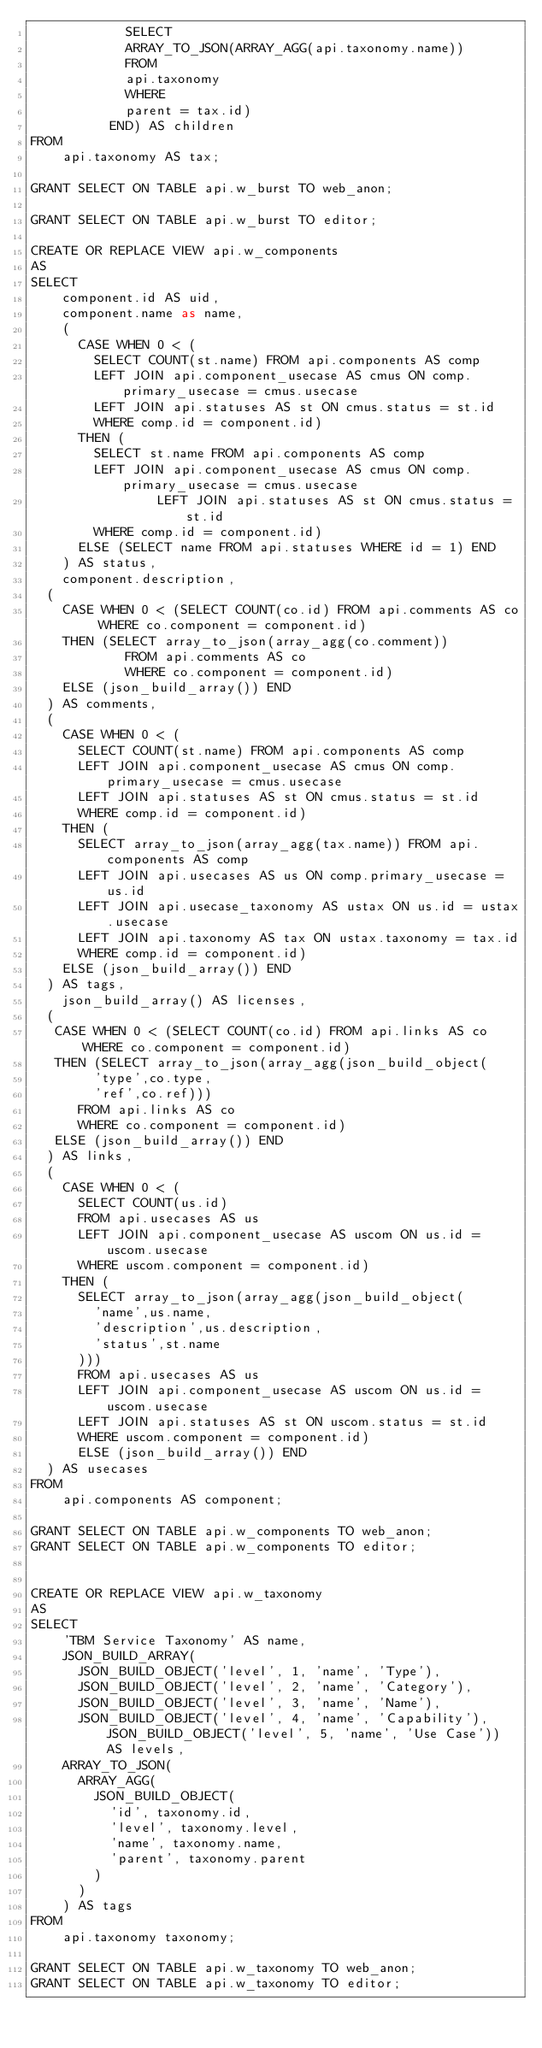<code> <loc_0><loc_0><loc_500><loc_500><_SQL_>            SELECT
            ARRAY_TO_JSON(ARRAY_AGG(api.taxonomy.name))
            FROM
            api.taxonomy
            WHERE
            parent = tax.id)
          END) AS children
FROM
    api.taxonomy AS tax;

GRANT SELECT ON TABLE api.w_burst TO web_anon;

GRANT SELECT ON TABLE api.w_burst TO editor;

CREATE OR REPLACE VIEW api.w_components
AS
SELECT
    component.id AS uid,
    component.name as name,
    (
      CASE WHEN 0 < (
        SELECT COUNT(st.name) FROM api.components AS comp
        LEFT JOIN api.component_usecase AS cmus ON comp.primary_usecase = cmus.usecase
        LEFT JOIN api.statuses AS st ON cmus.status = st.id
        WHERE comp.id = component.id)
      THEN (
        SELECT st.name FROM api.components AS comp
        LEFT JOIN api.component_usecase AS cmus ON comp.primary_usecase = cmus.usecase
                LEFT JOIN api.statuses AS st ON cmus.status = st.id
        WHERE comp.id = component.id)
      ELSE (SELECT name FROM api.statuses WHERE id = 1) END
    ) AS status,
    component.description,
	(
    CASE WHEN 0 < (SELECT COUNT(co.id) FROM api.comments AS co WHERE co.component = component.id)
    THEN (SELECT array_to_json(array_agg(co.comment))
            FROM api.comments AS co
            WHERE co.component = component.id)
    ELSE (json_build_array()) END
	) AS comments,
  (
    CASE WHEN 0 < (
      SELECT COUNT(st.name) FROM api.components AS comp
      LEFT JOIN api.component_usecase AS cmus ON comp.primary_usecase = cmus.usecase
      LEFT JOIN api.statuses AS st ON cmus.status = st.id
      WHERE comp.id = component.id)
    THEN (
      SELECT array_to_json(array_agg(tax.name)) FROM api.components AS comp
      LEFT JOIN api.usecases AS us ON comp.primary_usecase = us.id
      LEFT JOIN api.usecase_taxonomy AS ustax ON us.id = ustax.usecase
      LEFT JOIN api.taxonomy AS tax ON ustax.taxonomy = tax.id
      WHERE comp.id = component.id)
    ELSE (json_build_array()) END
  ) AS tags,
    json_build_array() AS licenses,
	(
	 CASE WHEN 0 < (SELECT COUNT(co.id) FROM api.links AS co WHERE co.component = component.id)
	 THEN (SELECT array_to_json(array_agg(json_build_object(
        'type',co.type,
        'ref',co.ref)))
      FROM api.links AS co
      WHERE co.component = component.id)
	 ELSE (json_build_array()) END
	) AS links,
  (
    CASE WHEN 0 < (
      SELECT COUNT(us.id)
      FROM api.usecases AS us
      LEFT JOIN api.component_usecase AS uscom ON us.id = uscom.usecase
      WHERE uscom.component = component.id)
    THEN (
      SELECT array_to_json(array_agg(json_build_object(
        'name',us.name,
        'description',us.description,
        'status',st.name
      )))
      FROM api.usecases AS us
      LEFT JOIN api.component_usecase AS uscom ON us.id = uscom.usecase
      LEFT JOIN api.statuses AS st ON uscom.status = st.id
      WHERE uscom.component = component.id)
      ELSE (json_build_array()) END
  ) AS usecases
FROM
    api.components AS component;

GRANT SELECT ON TABLE api.w_components TO web_anon;
GRANT SELECT ON TABLE api.w_components TO editor;


CREATE OR REPLACE VIEW api.w_taxonomy
AS
SELECT
    'TBM Service Taxonomy' AS name,
    JSON_BUILD_ARRAY(
      JSON_BUILD_OBJECT('level', 1, 'name', 'Type'),
      JSON_BUILD_OBJECT('level', 2, 'name', 'Category'),
      JSON_BUILD_OBJECT('level', 3, 'name', 'Name'),
      JSON_BUILD_OBJECT('level', 4, 'name', 'Capability'), JSON_BUILD_OBJECT('level', 5, 'name', 'Use Case')) AS levels,
    ARRAY_TO_JSON(
      ARRAY_AGG(
        JSON_BUILD_OBJECT(
          'id', taxonomy.id,
          'level', taxonomy.level,
          'name', taxonomy.name,
          'parent', taxonomy.parent
        )
      )
    ) AS tags
FROM
    api.taxonomy taxonomy;

GRANT SELECT ON TABLE api.w_taxonomy TO web_anon;
GRANT SELECT ON TABLE api.w_taxonomy TO editor;
</code> 